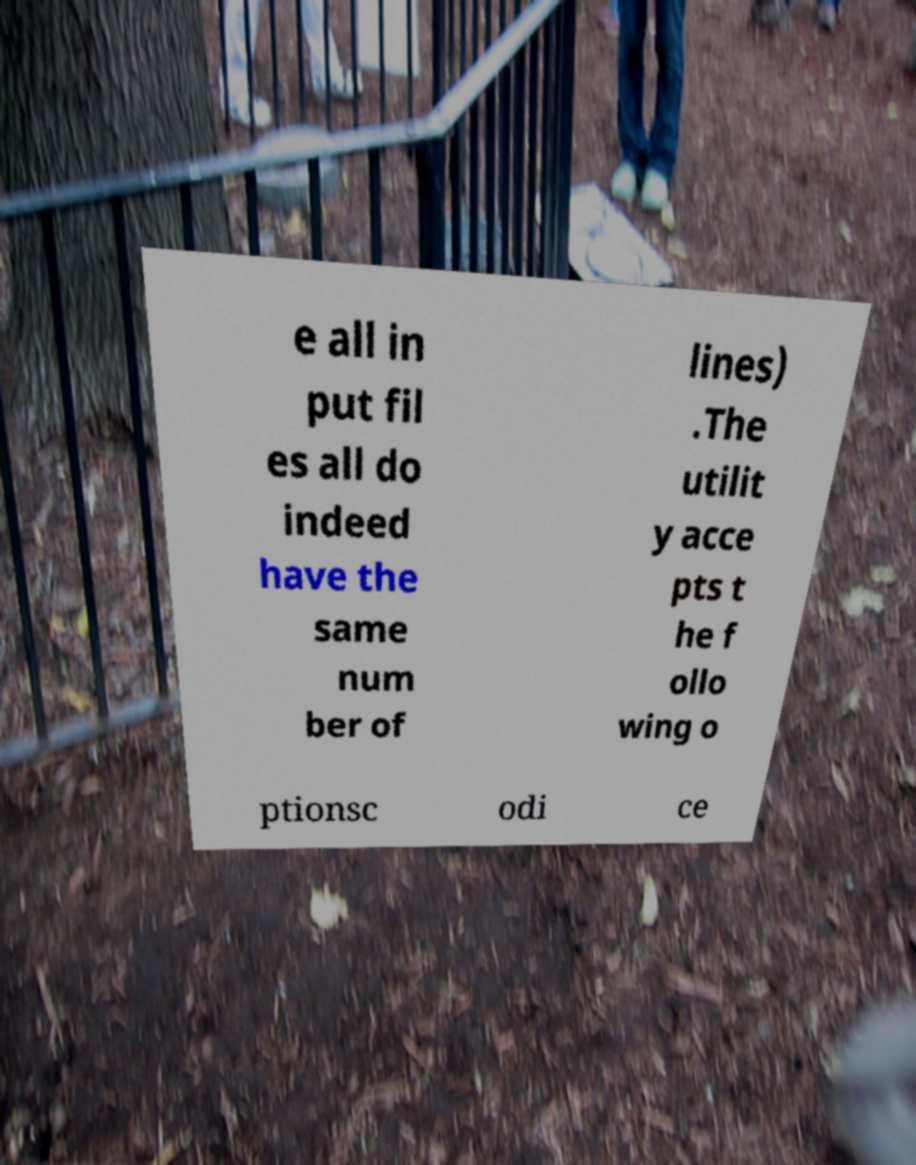What messages or text are displayed in this image? I need them in a readable, typed format. e all in put fil es all do indeed have the same num ber of lines) .The utilit y acce pts t he f ollo wing o ptionsc odi ce 